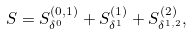<formula> <loc_0><loc_0><loc_500><loc_500>S = S _ { \delta ^ { 0 } } ^ { ( 0 , 1 ) } + S _ { \delta ^ { 1 } } ^ { ( 1 ) } + S _ { \delta ^ { 1 , 2 } } ^ { ( 2 ) } ,</formula> 